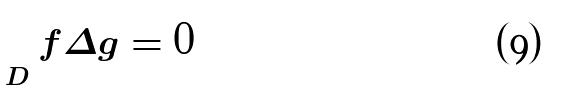<formula> <loc_0><loc_0><loc_500><loc_500>\int _ { D } f \Delta g = 0</formula> 